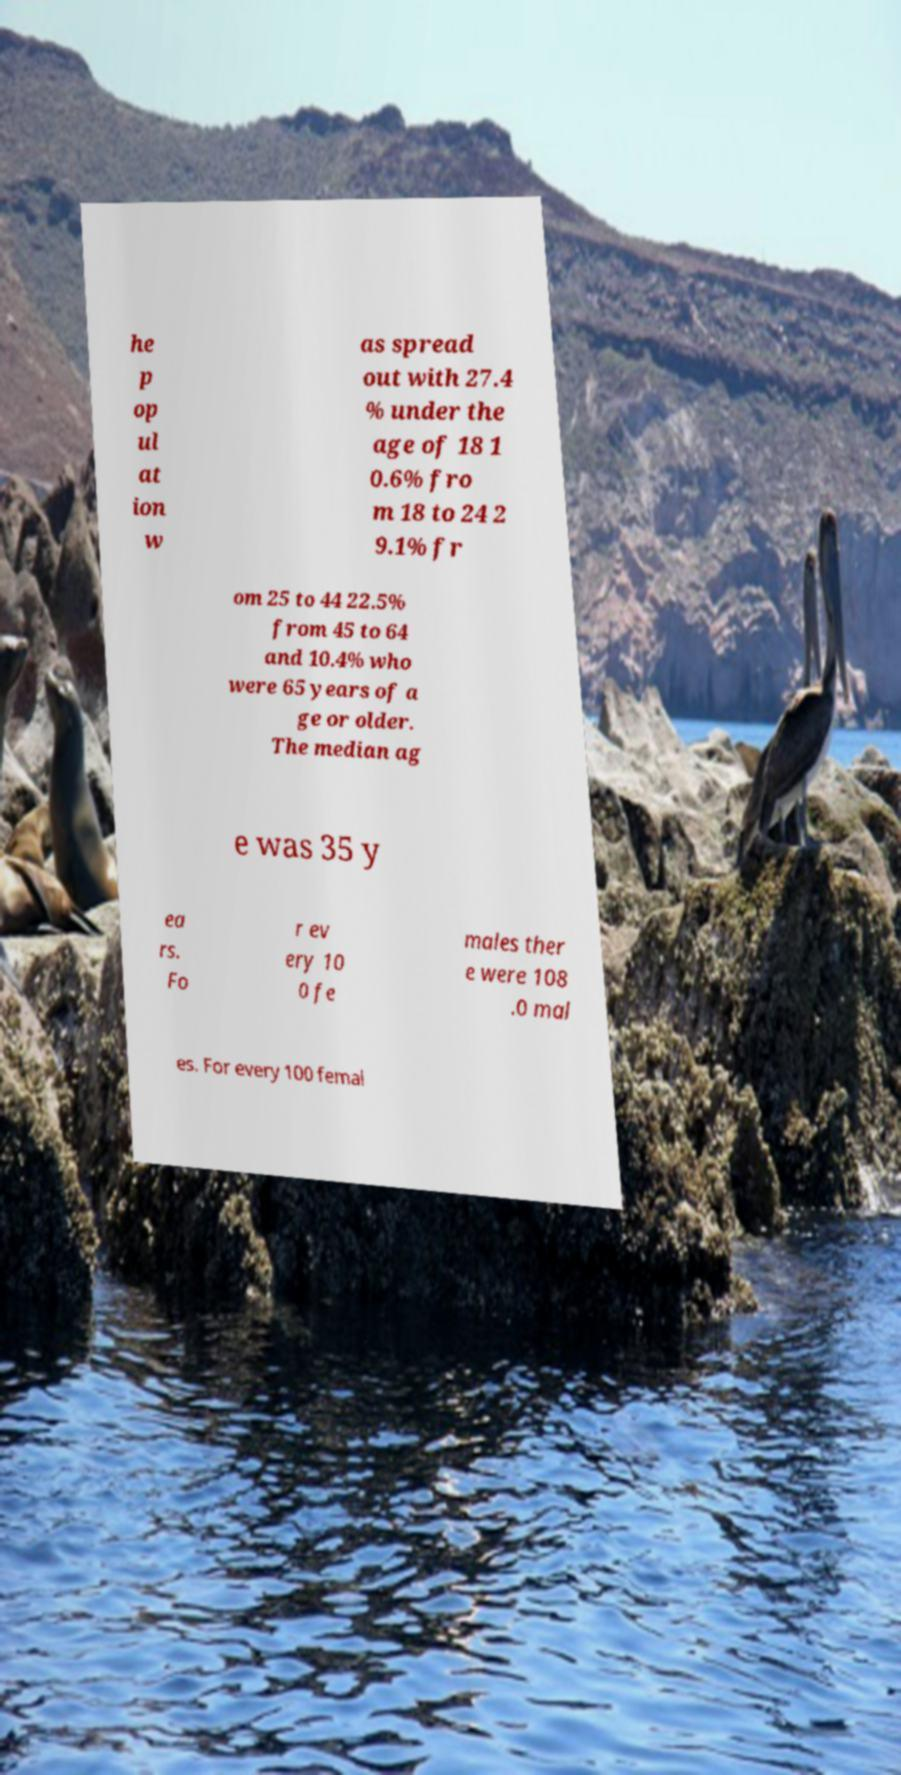For documentation purposes, I need the text within this image transcribed. Could you provide that? he p op ul at ion w as spread out with 27.4 % under the age of 18 1 0.6% fro m 18 to 24 2 9.1% fr om 25 to 44 22.5% from 45 to 64 and 10.4% who were 65 years of a ge or older. The median ag e was 35 y ea rs. Fo r ev ery 10 0 fe males ther e were 108 .0 mal es. For every 100 femal 